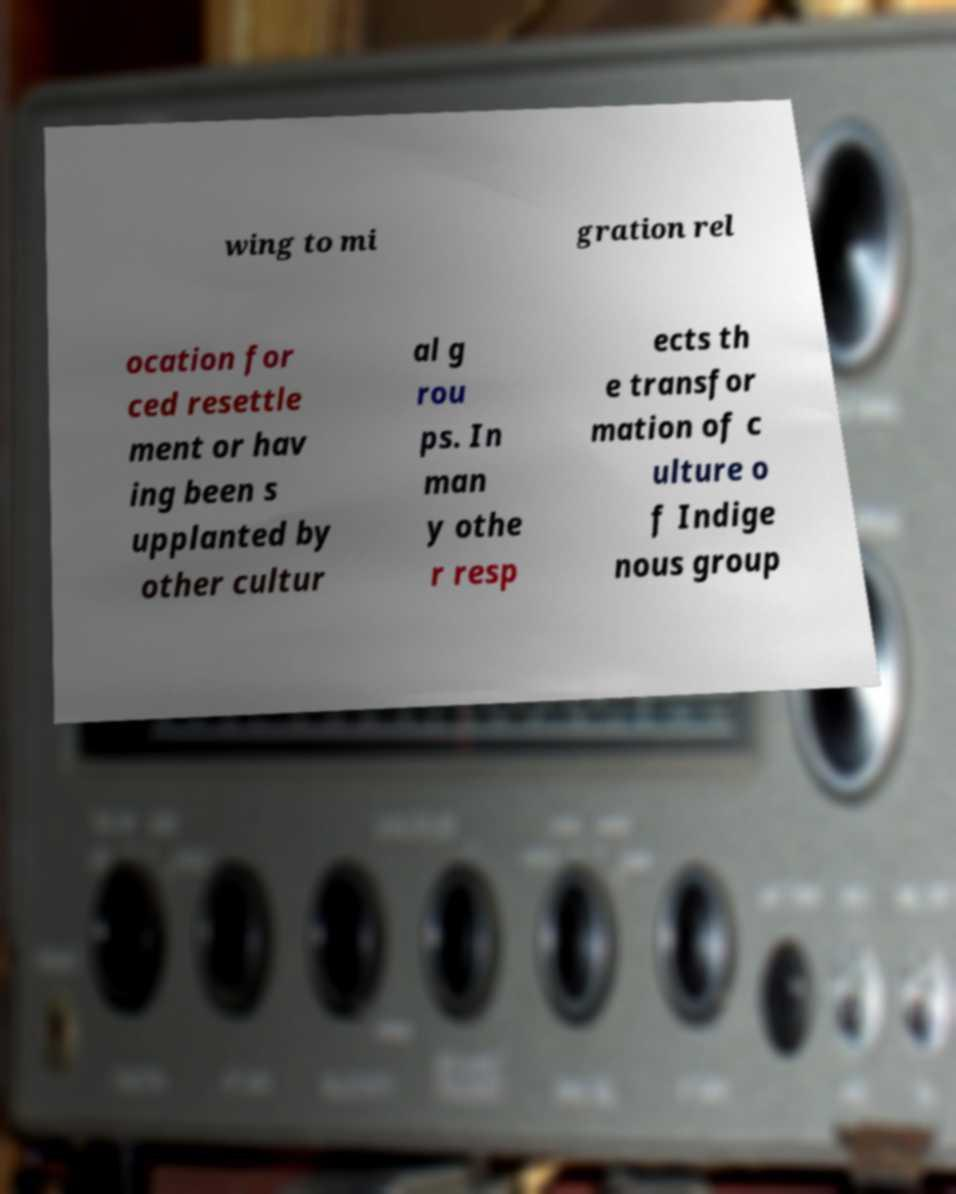There's text embedded in this image that I need extracted. Can you transcribe it verbatim? wing to mi gration rel ocation for ced resettle ment or hav ing been s upplanted by other cultur al g rou ps. In man y othe r resp ects th e transfor mation of c ulture o f Indige nous group 